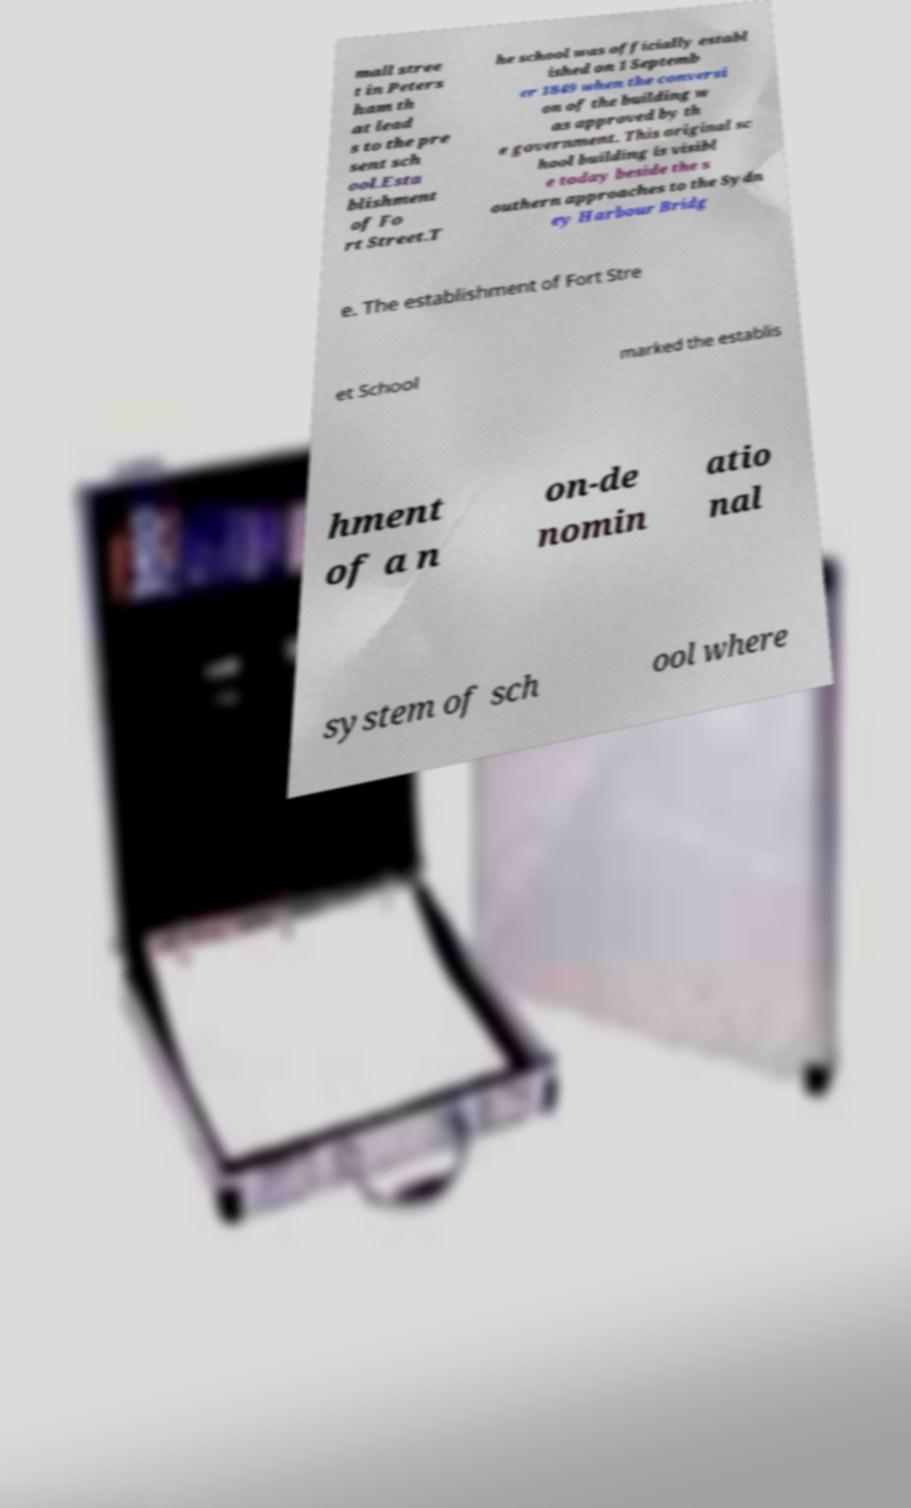I need the written content from this picture converted into text. Can you do that? mall stree t in Peters ham th at lead s to the pre sent sch ool.Esta blishment of Fo rt Street.T he school was officially establ ished on 1 Septemb er 1849 when the conversi on of the building w as approved by th e government. This original sc hool building is visibl e today beside the s outhern approaches to the Sydn ey Harbour Bridg e. The establishment of Fort Stre et School marked the establis hment of a n on-de nomin atio nal system of sch ool where 